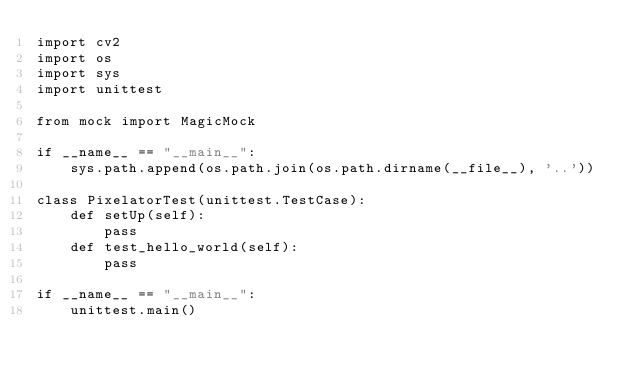<code> <loc_0><loc_0><loc_500><loc_500><_Python_>import cv2
import os
import sys
import unittest

from mock import MagicMock

if __name__ == "__main__":
    sys.path.append(os.path.join(os.path.dirname(__file__), '..'))

class PixelatorTest(unittest.TestCase):
    def setUp(self):
        pass
    def test_hello_world(self):
        pass

if __name__ == "__main__":
    unittest.main()

</code> 